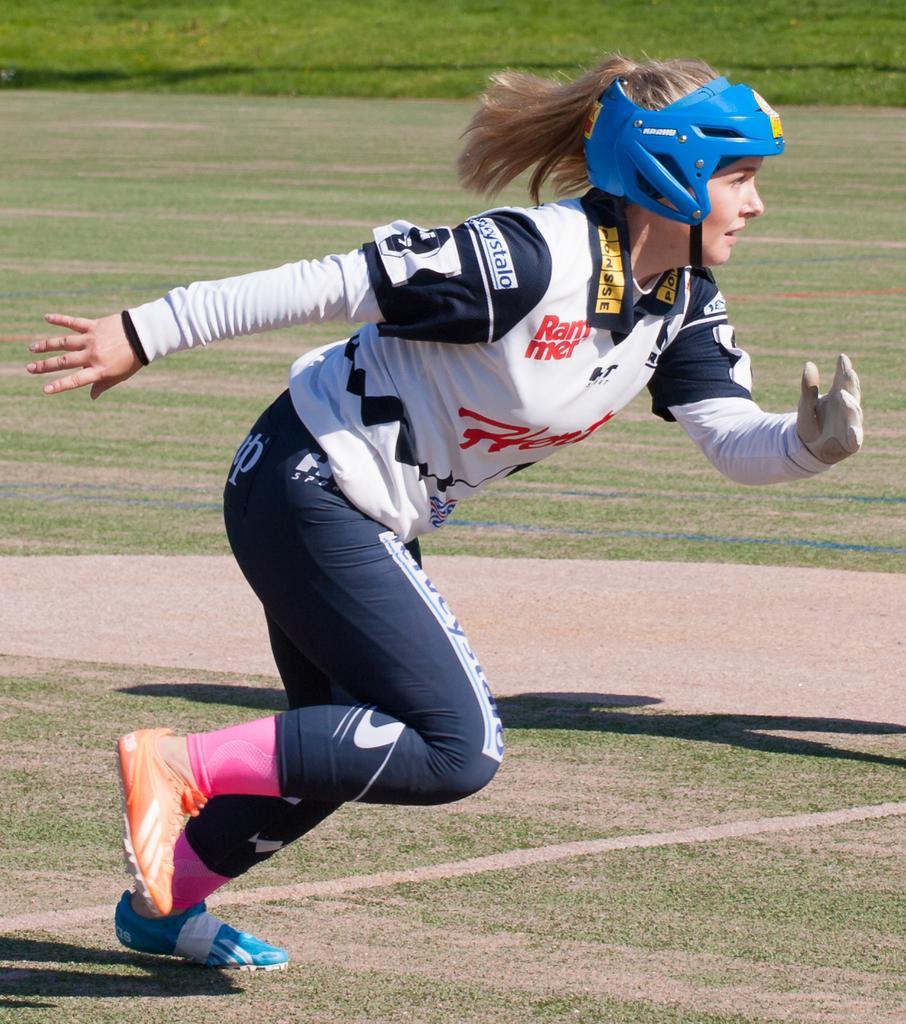Describe this image in one or two sentences. In the image there is a lady with a helmet on her head. And she is running. On the ground there is grass. 